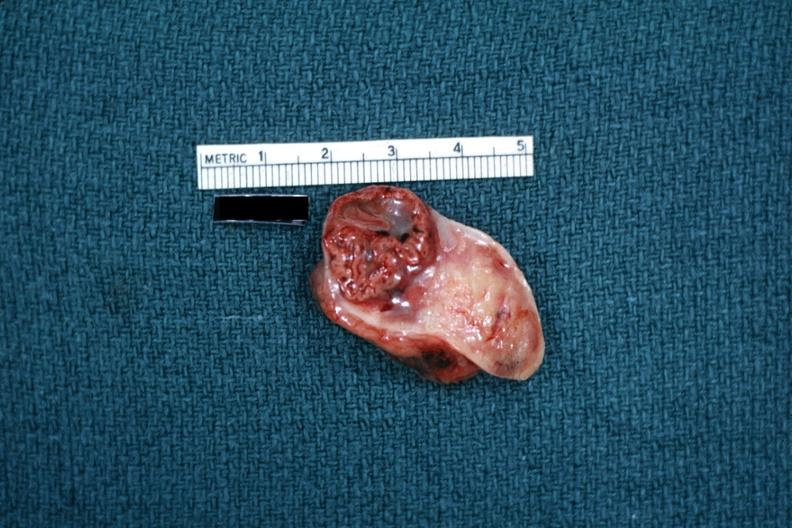what is present?
Answer the question using a single word or phrase. Ovary 